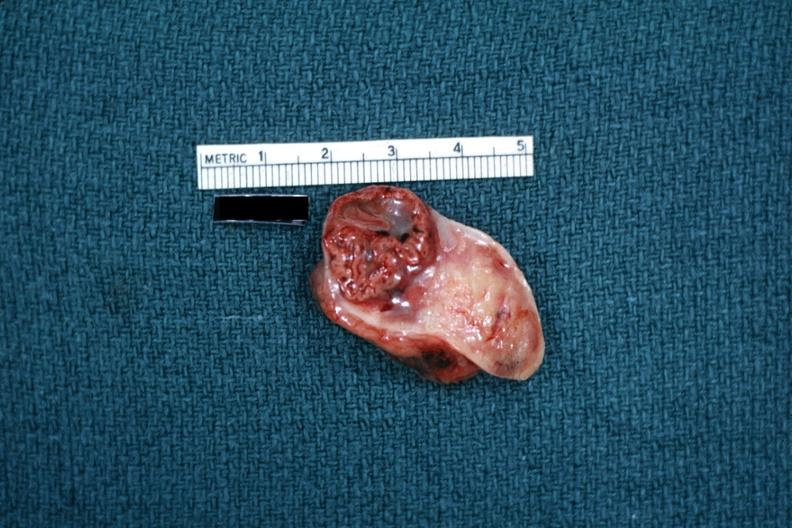what is present?
Answer the question using a single word or phrase. Ovary 